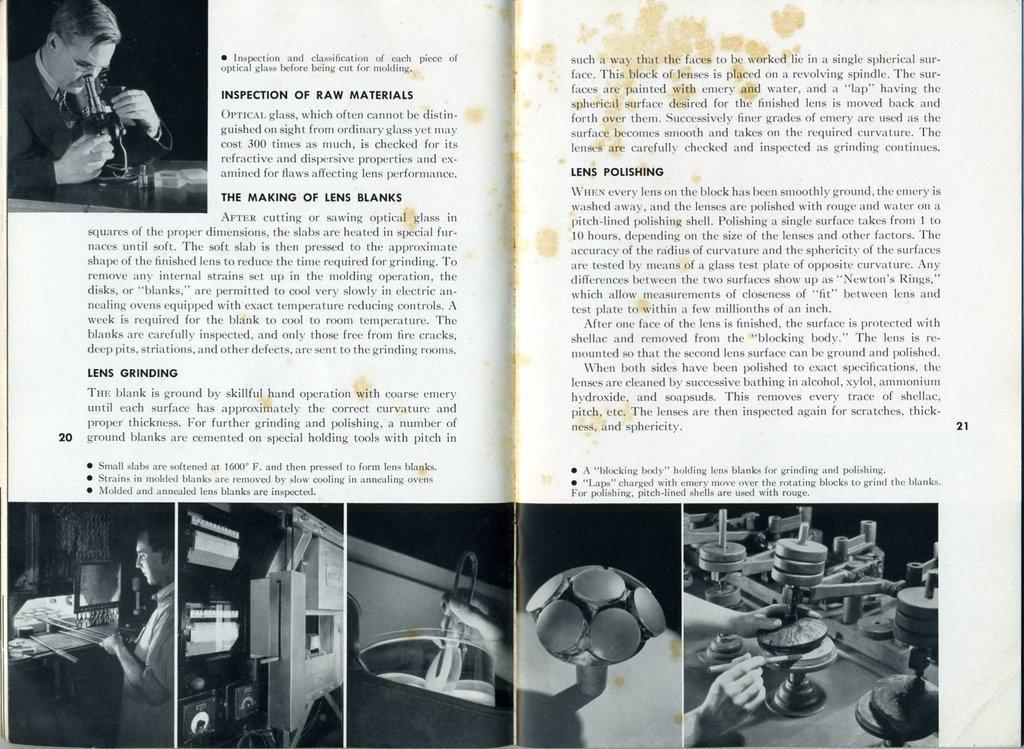Could you give a brief overview of what you see in this image? In the picture we can see a magazine with an image of a person holding something and looking into it and under it we can see information and below we can see some images with some things in it. 